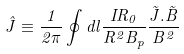Convert formula to latex. <formula><loc_0><loc_0><loc_500><loc_500>\hat { J } \equiv \frac { 1 } { 2 \pi } \oint d l \frac { I R _ { 0 } } { R ^ { 2 } B _ { p } } \frac { \vec { J } . \vec { B } } { B ^ { 2 } }</formula> 